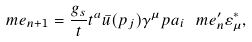<formula> <loc_0><loc_0><loc_500><loc_500>\ m e _ { n + 1 } = \frac { g _ { s } } { t } { t } ^ { a } \bar { u } ( p _ { j } ) \gamma ^ { \mu } p \sl a _ { i } \ m e ^ { \prime } _ { n } \varepsilon ^ { * } _ { \mu } ,</formula> 